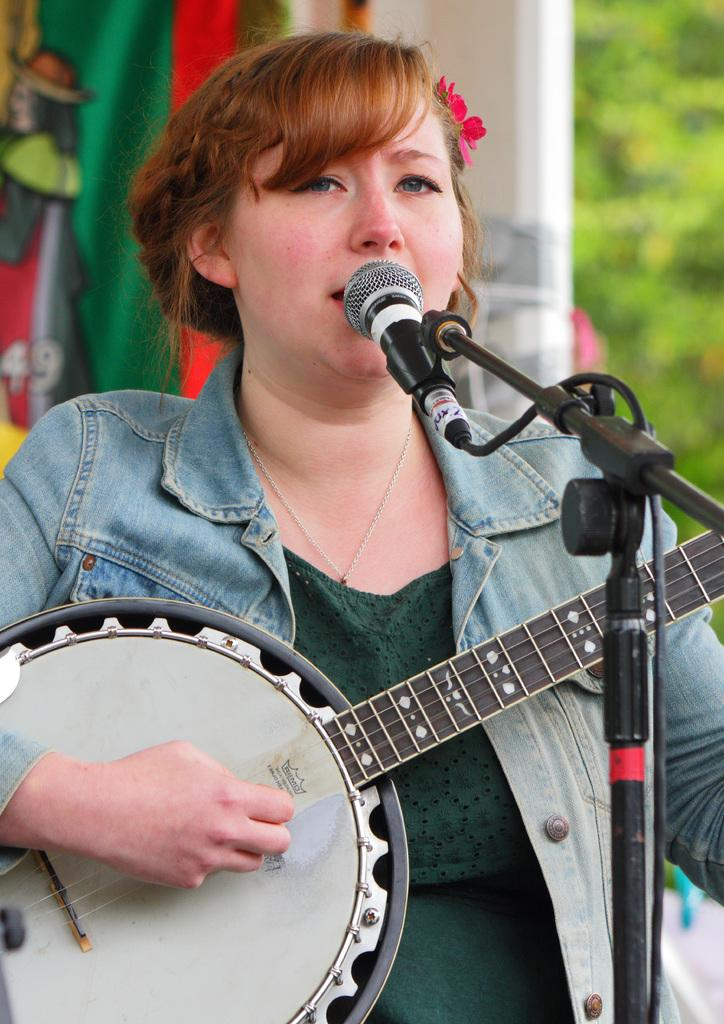What is the lady in the image doing? The lady in the image is playing guitar. What object is present that might be used for amplifying her voice? There is a microphone in the image. What can be seen in the background behind the lady? There is a cloth and trees visible in the background, as well as a wall. What is the lady's interest in the image? The provided facts do not mention the lady's interests, so we cannot determine her interest from the image. 